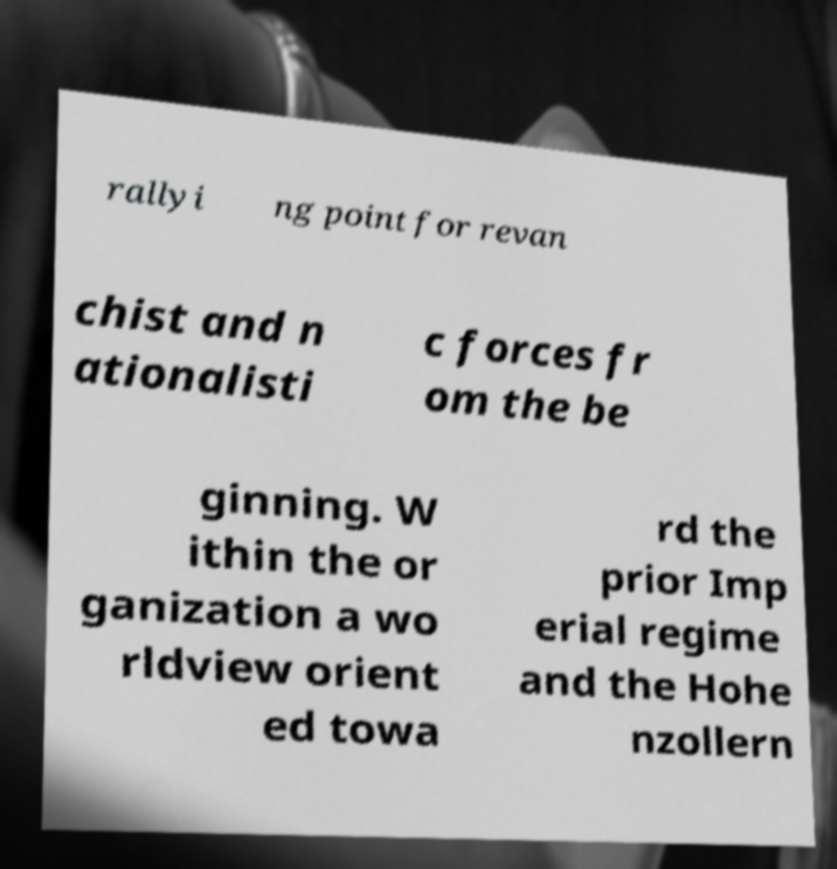Please read and relay the text visible in this image. What does it say? rallyi ng point for revan chist and n ationalisti c forces fr om the be ginning. W ithin the or ganization a wo rldview orient ed towa rd the prior Imp erial regime and the Hohe nzollern 